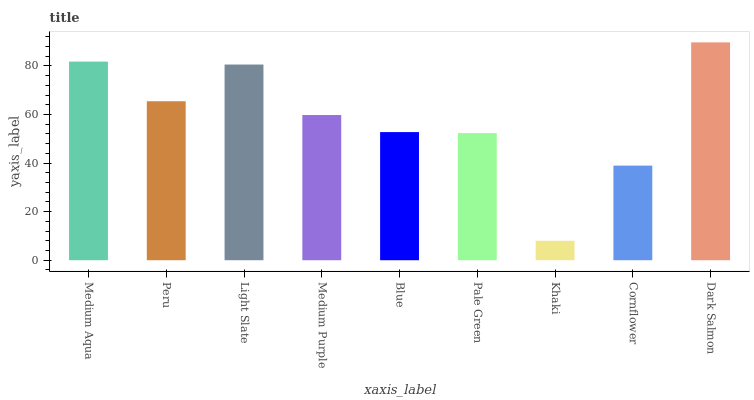Is Khaki the minimum?
Answer yes or no. Yes. Is Dark Salmon the maximum?
Answer yes or no. Yes. Is Peru the minimum?
Answer yes or no. No. Is Peru the maximum?
Answer yes or no. No. Is Medium Aqua greater than Peru?
Answer yes or no. Yes. Is Peru less than Medium Aqua?
Answer yes or no. Yes. Is Peru greater than Medium Aqua?
Answer yes or no. No. Is Medium Aqua less than Peru?
Answer yes or no. No. Is Medium Purple the high median?
Answer yes or no. Yes. Is Medium Purple the low median?
Answer yes or no. Yes. Is Cornflower the high median?
Answer yes or no. No. Is Light Slate the low median?
Answer yes or no. No. 